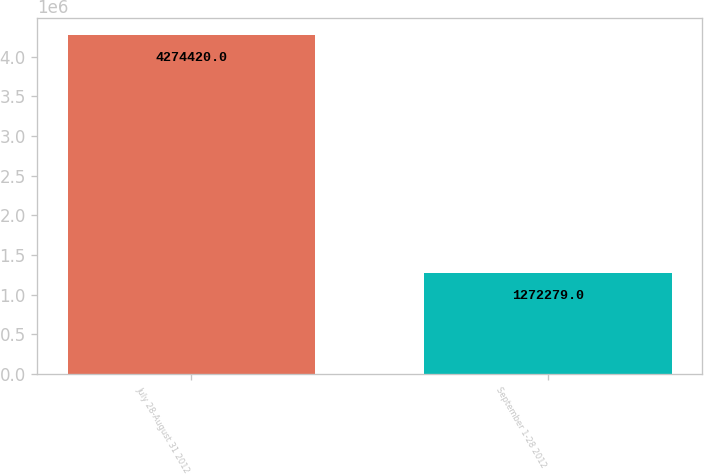Convert chart to OTSL. <chart><loc_0><loc_0><loc_500><loc_500><bar_chart><fcel>July 28-August 31 2012<fcel>September 1-28 2012<nl><fcel>4.27442e+06<fcel>1.27228e+06<nl></chart> 